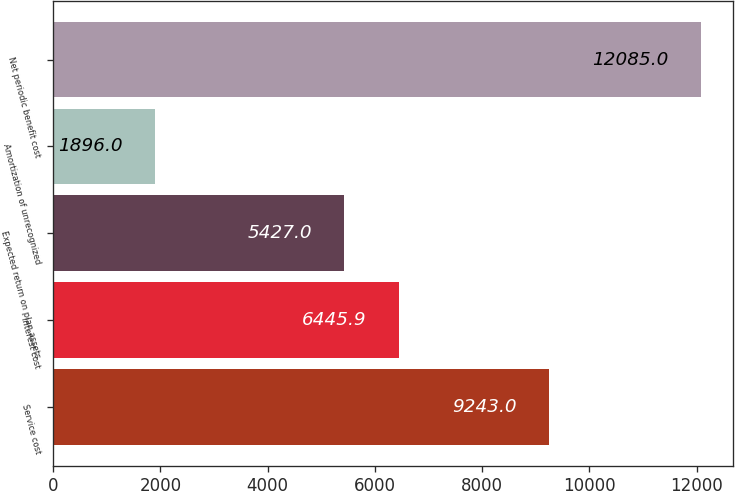Convert chart. <chart><loc_0><loc_0><loc_500><loc_500><bar_chart><fcel>Service cost<fcel>Interest cost<fcel>Expected return on plan assets<fcel>Amortization of unrecognized<fcel>Net periodic benefit cost<nl><fcel>9243<fcel>6445.9<fcel>5427<fcel>1896<fcel>12085<nl></chart> 